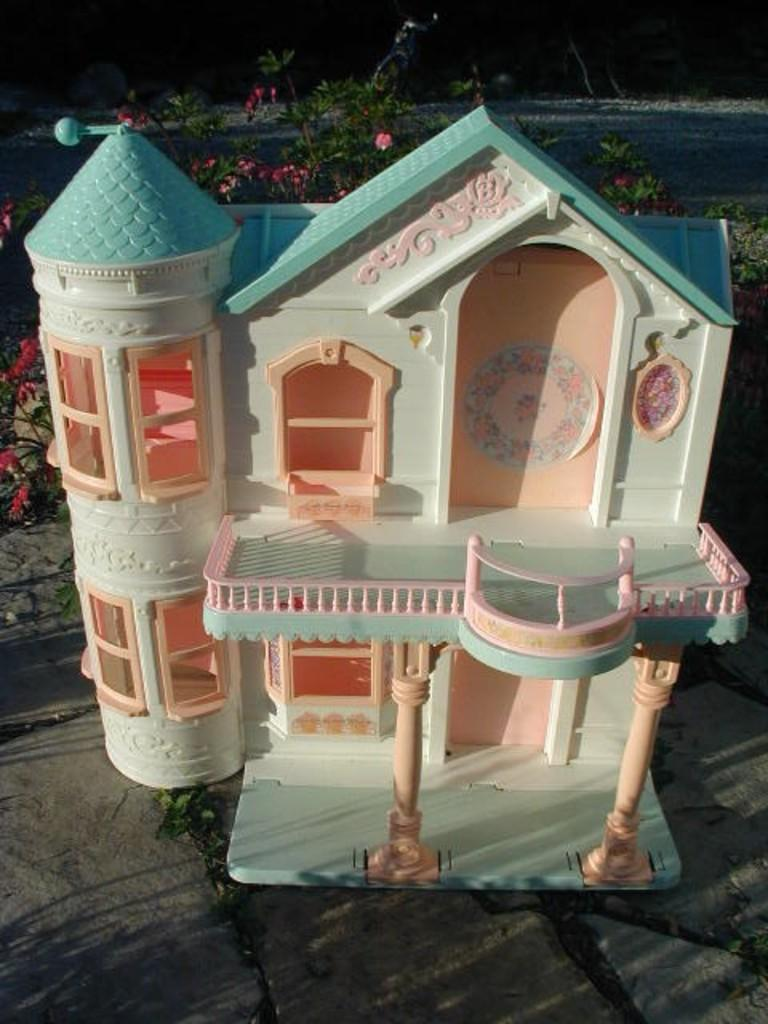What type of structure is present in the image? There is a puppy house in the image. What type of vegetation can be seen in the image? There are flower plants in the image. Is there any indication of a path or walkway in the image? Yes, there is a path visible in the image. Can you see a cow biting a hand in the image? No, there is no cow or hand present in the image. 